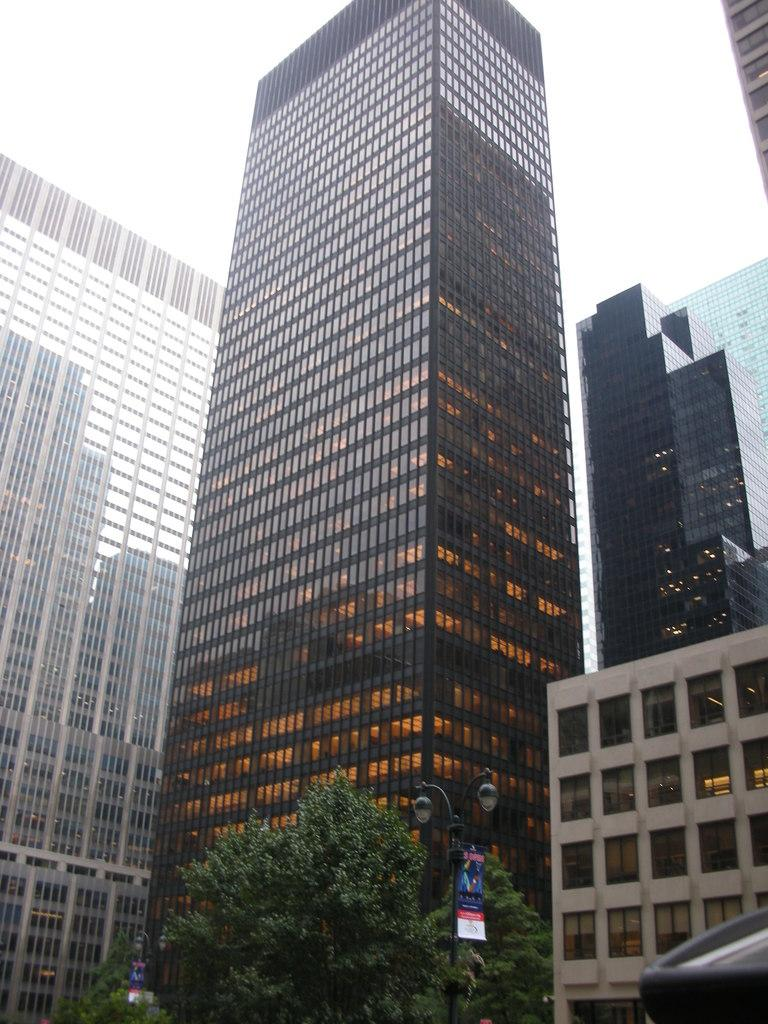What type of buildings are shown in the image? The buildings in the image have glass doors. What can be seen at the bottom of the image? Trees and light poles are visible at the bottom of the image. How does the boat navigate through the buildings in the image? There is no boat present in the image; it only features buildings with glass doors, trees, and light poles. 